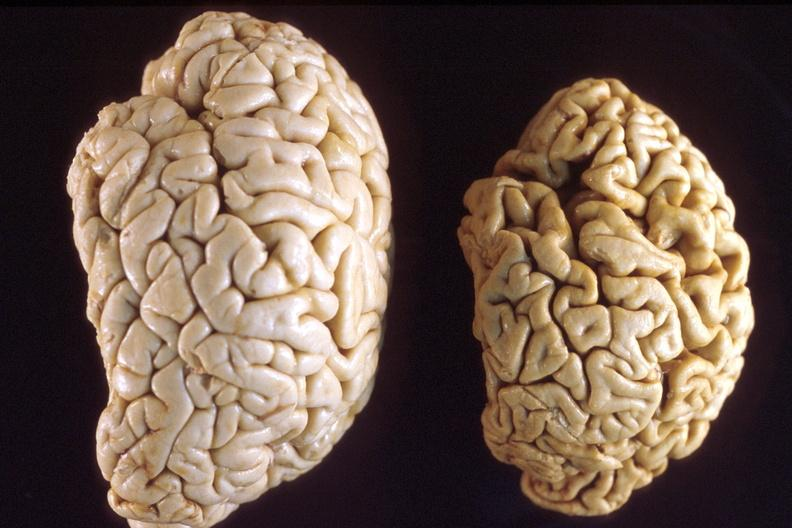what is present?
Answer the question using a single word or phrase. Nervous 